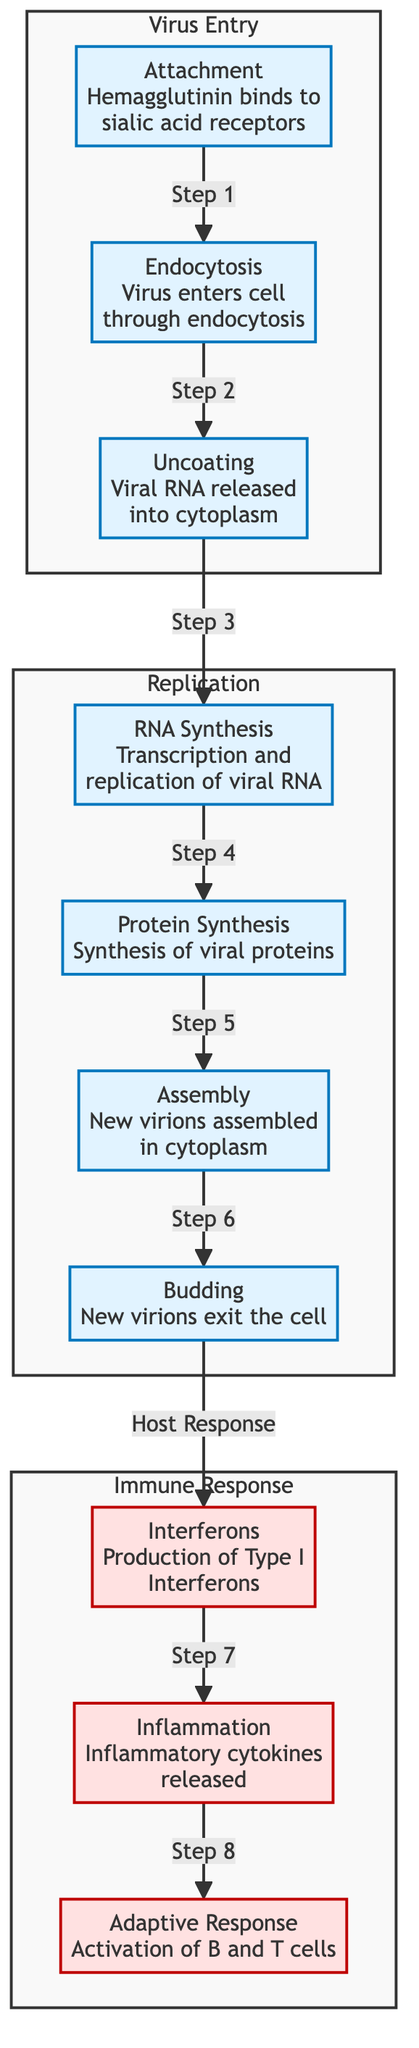What is the first step in the virus entry process? The diagram outlines the process of virus entry, beginning with the step labeled "Attachment," where hemagglutinin binds to sialic acid receptors. This is the starting point for the virus to enter the host cell.
Answer: Attachment How many main processes are depicted in the diagram? The diagram shows three main processes: Virus Entry, Replication, and Immune Response. By counting the labeled subgraph sections, we can confirm that there are three distinct processes shown.
Answer: 3 What is released into the cytoplasm during uncoating? In the Replication subgraph, during the "Uncoating" step, it is specified that viral RNA is released into the cytoplasm. This is a crucial part of the replication cycle because it allows the virus's genetic material to access the host cell's machinery.
Answer: Viral RNA Which components are involved in the adaptive immune response? The immune response section includes "Activation of B and T cells" as the final step after "Production of Type I Interferons" and "Inflammatory cytokines released." This specific activation signifies the adaptive immune response against the virus.
Answer: Activation of B and T cells In which step does the virus exit the host cell? The diagram indicates that the "Budding" step is when new virions exit the cell after assembly. This highlights the final stage of the replication process leading to the spread of the virus.
Answer: Budding What happens immediately after new virions are assembled? Following the "Assembly" step, the diagram shows that the next step is "Budding," which indicates a direct transition where the assembled virions prepare to exit the host cell. This connection emphasizes the sequential nature of viral replication.
Answer: New virions exit the cell Which immune response signal is produced first? From the diagram, the first immune response signal to be produced is "Type I Interferons," as indicated in the sequence following the host response to the viral infection. This step is crucial for the antiviral response in the infected host.
Answer: Production of Type I Interferons What triggers the release of inflammatory cytokines? According to the diagram, the release of inflammatory cytokines is triggered after the production of Type I Interferons, illustrating a progression in the immune response that helps in combating the influenza infection.
Answer: Inflammatory cytokines released 